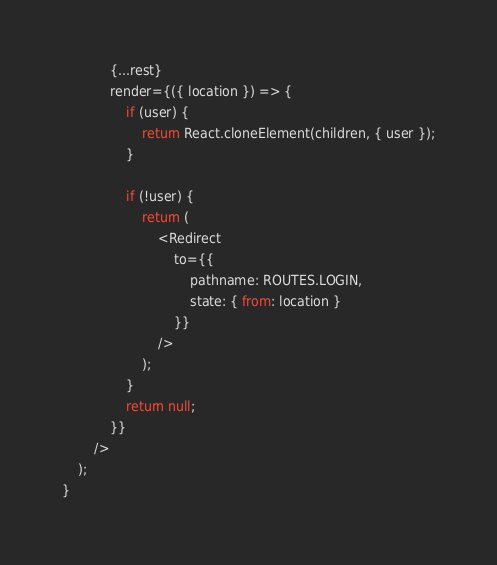Convert code to text. <code><loc_0><loc_0><loc_500><loc_500><_JavaScript_>            {...rest}
            render={({ location }) => {
                if (user) {
                    return React.cloneElement(children, { user });
                }

                if (!user) {
                    return (
                        <Redirect
                            to={{
                                pathname: ROUTES.LOGIN,
                                state: { from: location }
                            }}
                        />
                    );
                }
                return null;
            }}
        />
    );
}</code> 